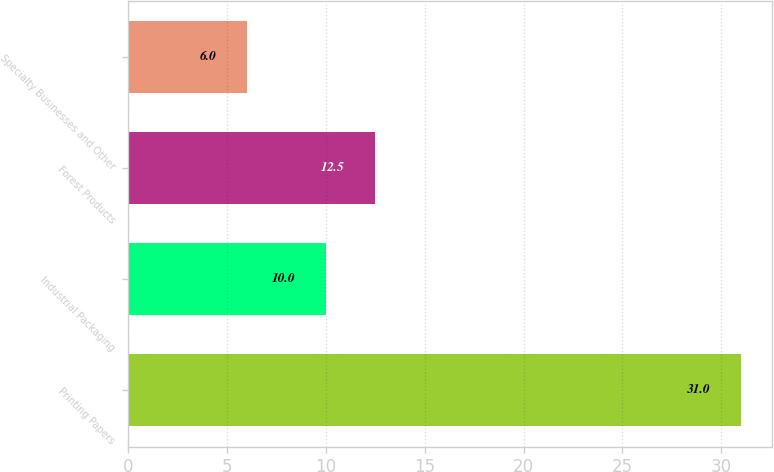Convert chart. <chart><loc_0><loc_0><loc_500><loc_500><bar_chart><fcel>Printing Papers<fcel>Industrial Packaging<fcel>Forest Products<fcel>Specialty Businesses and Other<nl><fcel>31<fcel>10<fcel>12.5<fcel>6<nl></chart> 